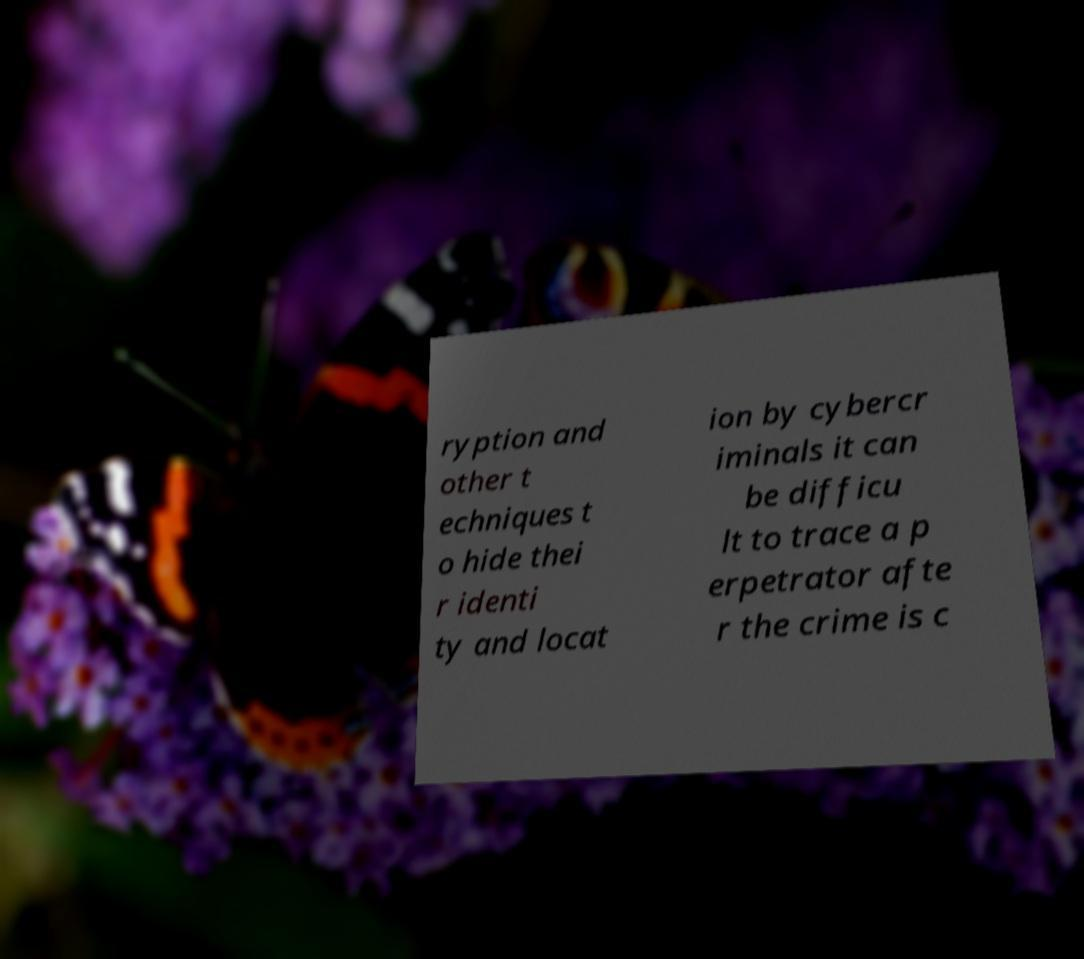There's text embedded in this image that I need extracted. Can you transcribe it verbatim? ryption and other t echniques t o hide thei r identi ty and locat ion by cybercr iminals it can be difficu lt to trace a p erpetrator afte r the crime is c 